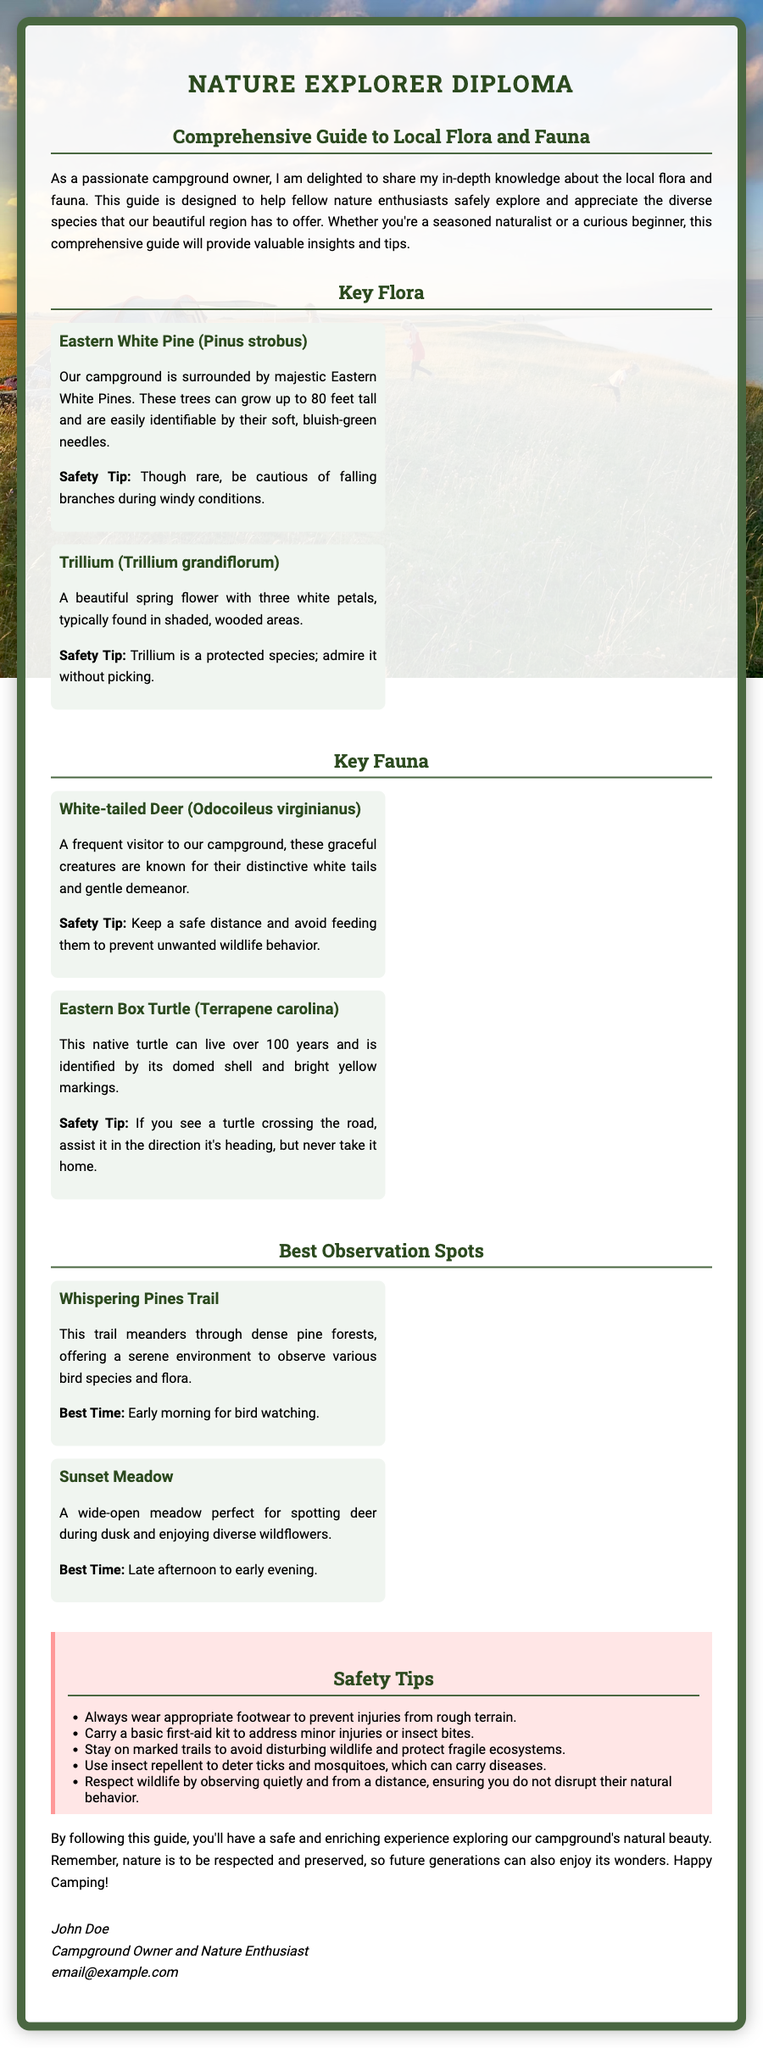What is the title of the diploma? The title of the diploma is prominently displayed at the top of the document.
Answer: Nature Explorer Diploma What is the first plant listed in the Key Flora section? The first plant mentioned in the Key Flora section is listed in the corresponding item.
Answer: Eastern White Pine (Pinus strobus) Which animal is frequently seen at the campground? The animal that is mentioned as a frequent visitor is specified under the Key Fauna section.
Answer: White-tailed Deer (Odocoileus virginianus) What is the best time for bird watching on Whispering Pines Trail? The best time for bird watching is indicated in the description of the observation spot.
Answer: Early morning What safety tip is suggested for observing wildlife? One safety tip related to wildlife observation is explicitly mentioned in the document.
Answer: Observe quietly and from a distance How many species are listed in the Key Fauna section? The number of species can be determined by counting the entries provided in the Key Fauna section.
Answer: 2 What is advised to carry to address minor injuries? The advice regarding what to carry for minor injuries is mentioned in the Safety Tips section.
Answer: A basic first-aid kit Which spot is perfect for spotting deer during dusk? The spot perfect for observing deer at dusk is specifically named in the document.
Answer: Sunset Meadow What type of diploma is being offered? The unique type of document provided can be ascertained from the title section.
Answer: Diploma 